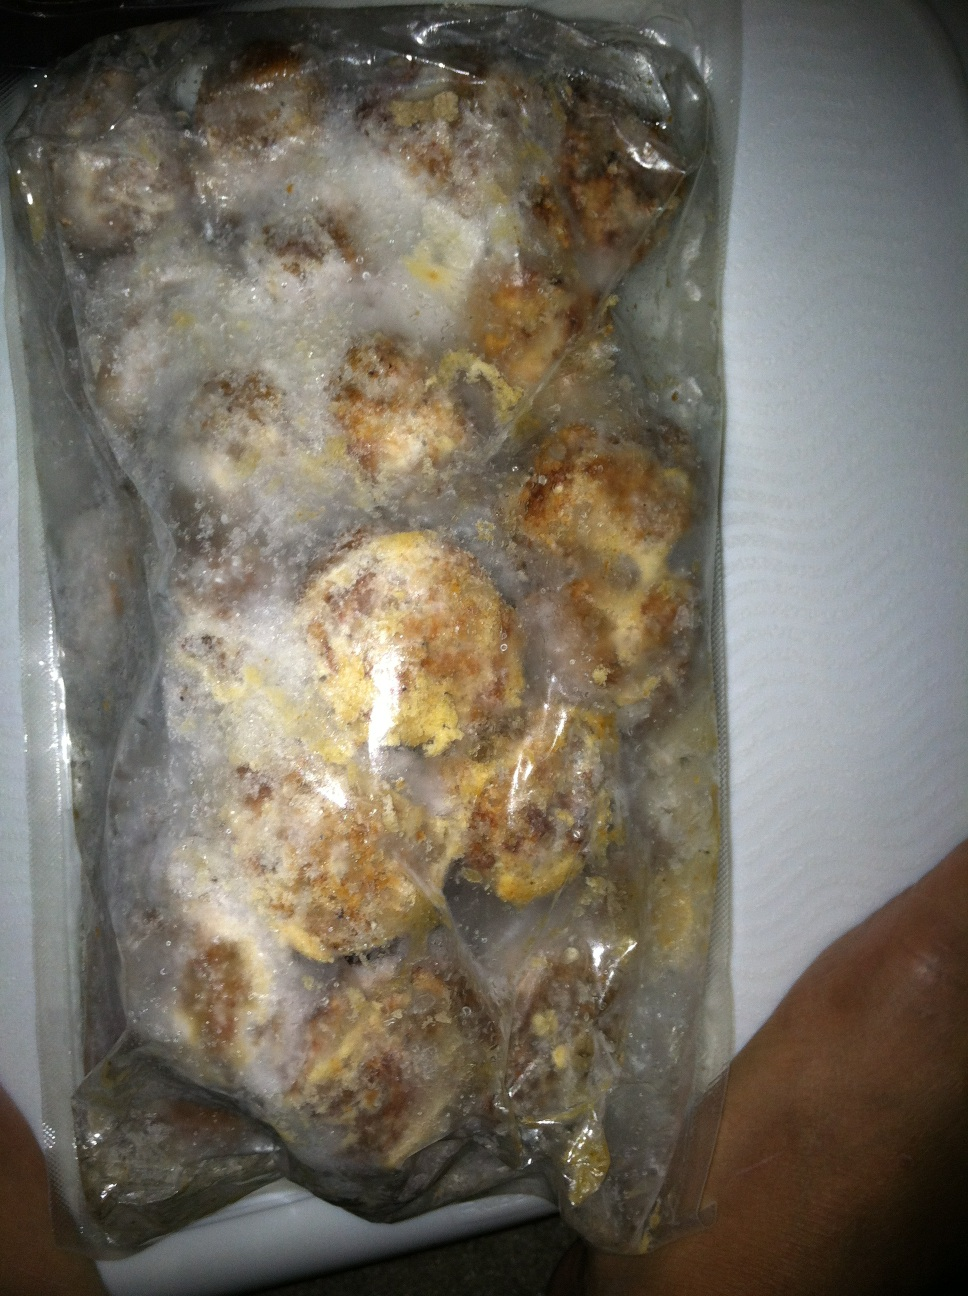Think of a very imaginative and wild question about this frozen package. If these meatballs could talk, what stories of culinary adventures would they share about the various kitchens they’ve been prepared in and the spices they’ve encountered? 